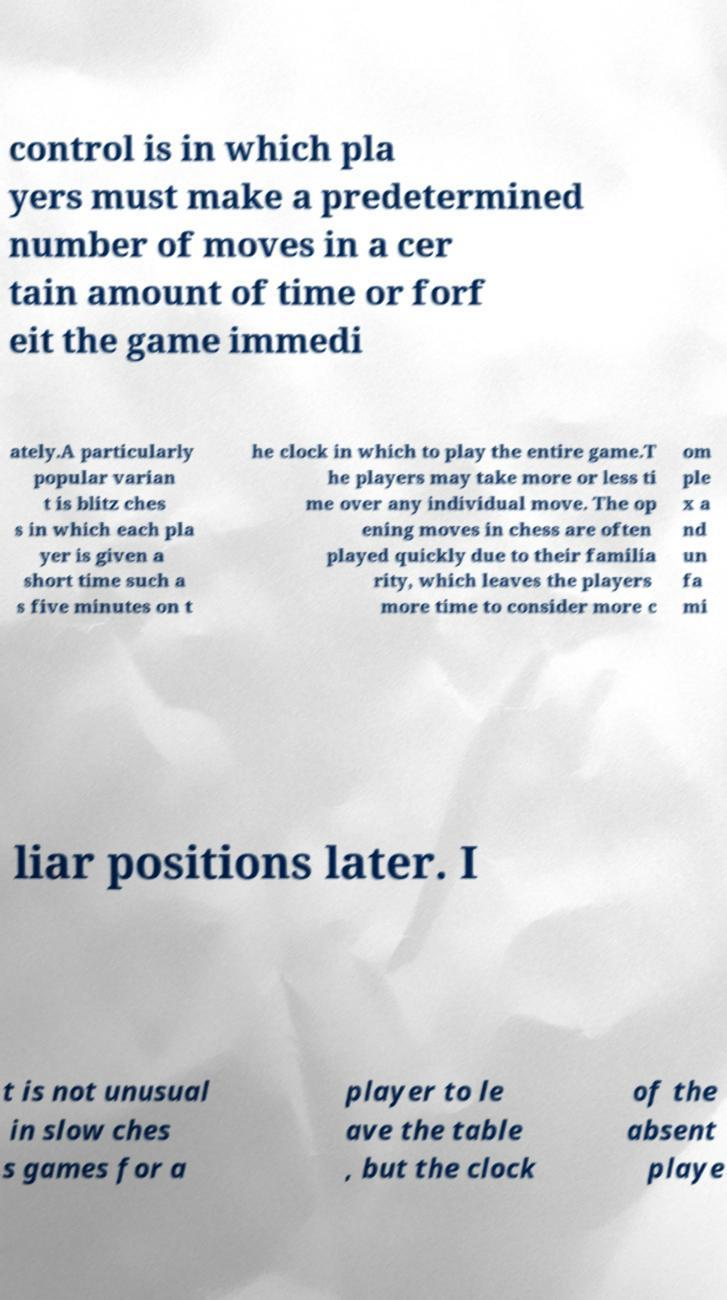For documentation purposes, I need the text within this image transcribed. Could you provide that? control is in which pla yers must make a predetermined number of moves in a cer tain amount of time or forf eit the game immedi ately.A particularly popular varian t is blitz ches s in which each pla yer is given a short time such a s five minutes on t he clock in which to play the entire game.T he players may take more or less ti me over any individual move. The op ening moves in chess are often played quickly due to their familia rity, which leaves the players more time to consider more c om ple x a nd un fa mi liar positions later. I t is not unusual in slow ches s games for a player to le ave the table , but the clock of the absent playe 